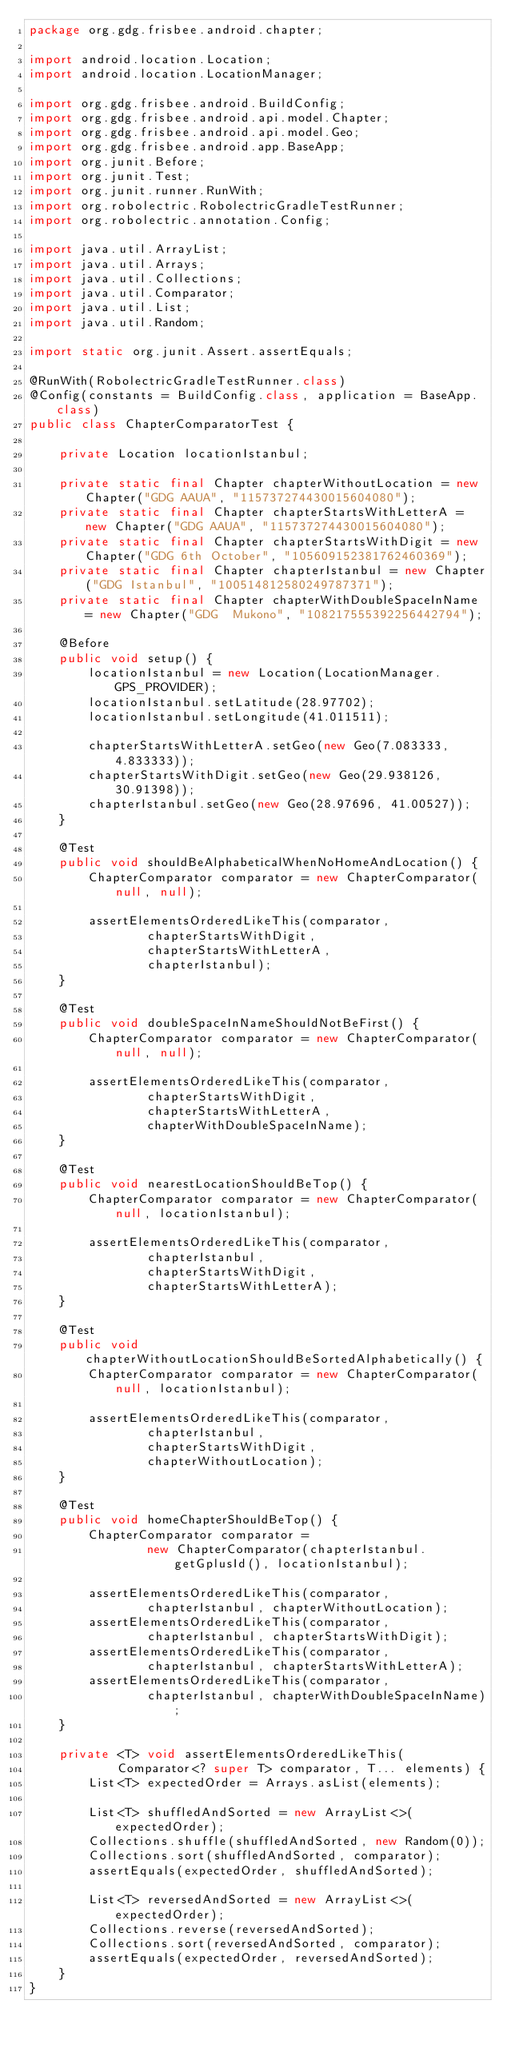<code> <loc_0><loc_0><loc_500><loc_500><_Java_>package org.gdg.frisbee.android.chapter;

import android.location.Location;
import android.location.LocationManager;

import org.gdg.frisbee.android.BuildConfig;
import org.gdg.frisbee.android.api.model.Chapter;
import org.gdg.frisbee.android.api.model.Geo;
import org.gdg.frisbee.android.app.BaseApp;
import org.junit.Before;
import org.junit.Test;
import org.junit.runner.RunWith;
import org.robolectric.RobolectricGradleTestRunner;
import org.robolectric.annotation.Config;

import java.util.ArrayList;
import java.util.Arrays;
import java.util.Collections;
import java.util.Comparator;
import java.util.List;
import java.util.Random;

import static org.junit.Assert.assertEquals;

@RunWith(RobolectricGradleTestRunner.class)
@Config(constants = BuildConfig.class, application = BaseApp.class)
public class ChapterComparatorTest {

    private Location locationIstanbul;

    private static final Chapter chapterWithoutLocation = new Chapter("GDG AAUA", "115737274430015604080");
    private static final Chapter chapterStartsWithLetterA = new Chapter("GDG AAUA", "115737274430015604080");
    private static final Chapter chapterStartsWithDigit = new Chapter("GDG 6th October", "105609152381762460369");
    private static final Chapter chapterIstanbul = new Chapter("GDG Istanbul", "100514812580249787371");
    private static final Chapter chapterWithDoubleSpaceInName = new Chapter("GDG  Mukono", "108217555392256442794");

    @Before
    public void setup() {
        locationIstanbul = new Location(LocationManager.GPS_PROVIDER);
        locationIstanbul.setLatitude(28.97702);
        locationIstanbul.setLongitude(41.011511);

        chapterStartsWithLetterA.setGeo(new Geo(7.083333, 4.833333));
        chapterStartsWithDigit.setGeo(new Geo(29.938126, 30.91398));
        chapterIstanbul.setGeo(new Geo(28.97696, 41.00527));
    }

    @Test
    public void shouldBeAlphabeticalWhenNoHomeAndLocation() {
        ChapterComparator comparator = new ChapterComparator(null, null);

        assertElementsOrderedLikeThis(comparator,
                chapterStartsWithDigit,
                chapterStartsWithLetterA,
                chapterIstanbul);
    }

    @Test
    public void doubleSpaceInNameShouldNotBeFirst() {
        ChapterComparator comparator = new ChapterComparator(null, null);

        assertElementsOrderedLikeThis(comparator,
                chapterStartsWithDigit,
                chapterStartsWithLetterA,
                chapterWithDoubleSpaceInName);
    }

    @Test
    public void nearestLocationShouldBeTop() {
        ChapterComparator comparator = new ChapterComparator(null, locationIstanbul);

        assertElementsOrderedLikeThis(comparator,
                chapterIstanbul,
                chapterStartsWithDigit,
                chapterStartsWithLetterA);
    }

    @Test
    public void chapterWithoutLocationShouldBeSortedAlphabetically() {
        ChapterComparator comparator = new ChapterComparator(null, locationIstanbul);

        assertElementsOrderedLikeThis(comparator,
                chapterIstanbul,
                chapterStartsWithDigit,
                chapterWithoutLocation);
    }

    @Test
    public void homeChapterShouldBeTop() {
        ChapterComparator comparator =
                new ChapterComparator(chapterIstanbul.getGplusId(), locationIstanbul);

        assertElementsOrderedLikeThis(comparator,
                chapterIstanbul, chapterWithoutLocation);
        assertElementsOrderedLikeThis(comparator,
                chapterIstanbul, chapterStartsWithDigit);
        assertElementsOrderedLikeThis(comparator,
                chapterIstanbul, chapterStartsWithLetterA);
        assertElementsOrderedLikeThis(comparator,
                chapterIstanbul, chapterWithDoubleSpaceInName);
    }

    private <T> void assertElementsOrderedLikeThis(
            Comparator<? super T> comparator, T... elements) {
        List<T> expectedOrder = Arrays.asList(elements);

        List<T> shuffledAndSorted = new ArrayList<>(expectedOrder);
        Collections.shuffle(shuffledAndSorted, new Random(0));
        Collections.sort(shuffledAndSorted, comparator);
        assertEquals(expectedOrder, shuffledAndSorted);

        List<T> reversedAndSorted = new ArrayList<>(expectedOrder);
        Collections.reverse(reversedAndSorted);
        Collections.sort(reversedAndSorted, comparator);
        assertEquals(expectedOrder, reversedAndSorted);
    }
}
</code> 